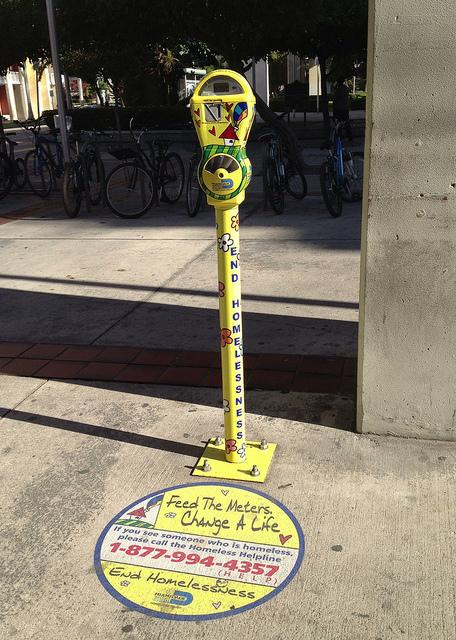What are they hoping to collect? change 